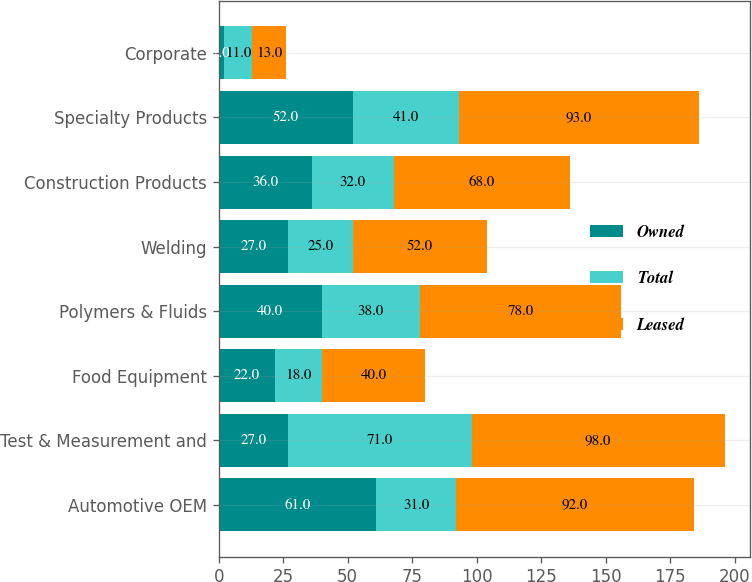Convert chart to OTSL. <chart><loc_0><loc_0><loc_500><loc_500><stacked_bar_chart><ecel><fcel>Automotive OEM<fcel>Test & Measurement and<fcel>Food Equipment<fcel>Polymers & Fluids<fcel>Welding<fcel>Construction Products<fcel>Specialty Products<fcel>Corporate<nl><fcel>Owned<fcel>61<fcel>27<fcel>22<fcel>40<fcel>27<fcel>36<fcel>52<fcel>2<nl><fcel>Total<fcel>31<fcel>71<fcel>18<fcel>38<fcel>25<fcel>32<fcel>41<fcel>11<nl><fcel>Leased<fcel>92<fcel>98<fcel>40<fcel>78<fcel>52<fcel>68<fcel>93<fcel>13<nl></chart> 